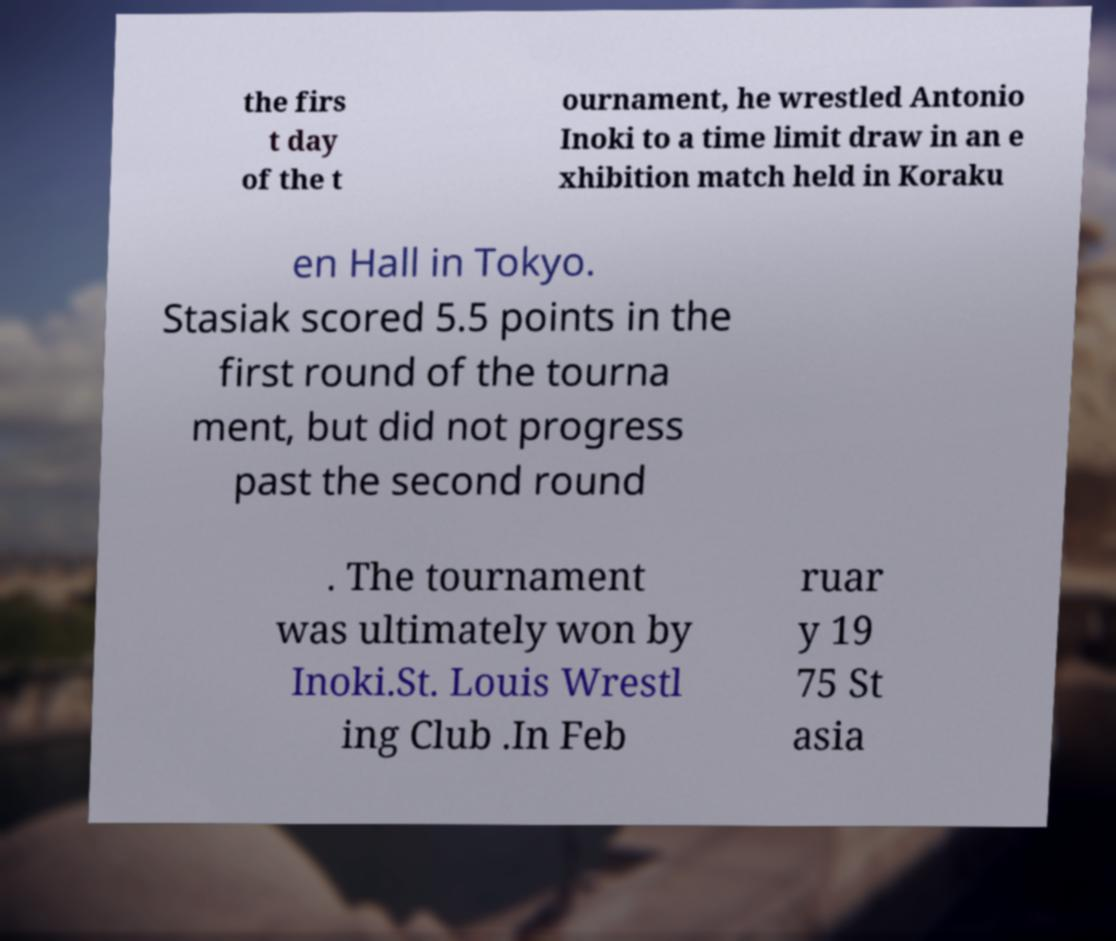Can you read and provide the text displayed in the image?This photo seems to have some interesting text. Can you extract and type it out for me? the firs t day of the t ournament, he wrestled Antonio Inoki to a time limit draw in an e xhibition match held in Koraku en Hall in Tokyo. Stasiak scored 5.5 points in the first round of the tourna ment, but did not progress past the second round . The tournament was ultimately won by Inoki.St. Louis Wrestl ing Club .In Feb ruar y 19 75 St asia 